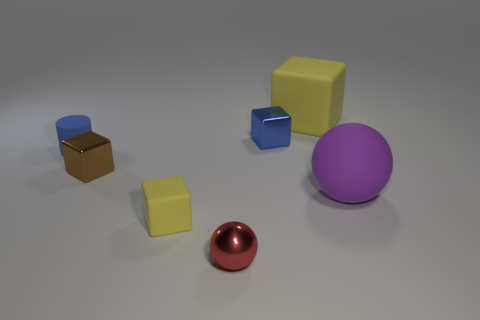Add 2 big cyan matte cubes. How many objects exist? 9 Subtract all cylinders. How many objects are left? 6 Add 5 brown blocks. How many brown blocks are left? 6 Add 2 blue blocks. How many blue blocks exist? 3 Subtract 1 blue cylinders. How many objects are left? 6 Subtract all rubber objects. Subtract all balls. How many objects are left? 1 